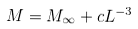Convert formula to latex. <formula><loc_0><loc_0><loc_500><loc_500>M = M _ { \infty } + c L ^ { - 3 }</formula> 